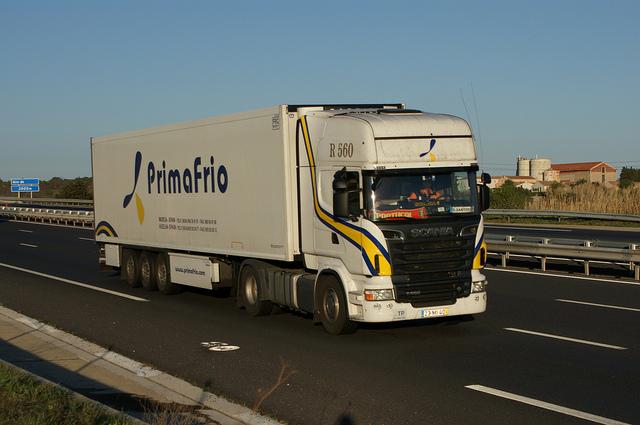What is this truck used for?
Answer briefly. Hauling goods. What kind of truck is this?
Answer briefly. Semi. Does this truck have a ladder in the back?
Quick response, please. No. What is the brand of the truck?
Give a very brief answer. Scania. Is the truck parked?
Short answer required. No. What color is the vehicle?
Concise answer only. White. Is the truck at a stop?
Quick response, please. No. What is written on the truck?
Answer briefly. Primafrio. What is the name of this truck?
Short answer required. Primafrio. Is this a house?
Short answer required. No. What color is the lead truck?
Short answer required. White. Is the truck traveling on an interstate?
Answer briefly. Yes. Is the person standing on the truck?
Short answer required. No. How many red braces can be seen?
Quick response, please. 0. Is this area rural?
Short answer required. Yes. Is the truck going to turn left?
Quick response, please. No. Is this a tow truck?
Quick response, please. No. Why is the roadway shiny?
Concise answer only. New. What are the round buildings in the background?
Be succinct. Silos. How many wheels are visible?
Quick response, please. 5. Is the vehicle moving?
Give a very brief answer. Yes. What kind of weather are they driving into?
Short answer required. Clear. Is this truck being inspected for illegal cargo?
Answer briefly. No. What is this truck transporting?
Answer briefly. Goods. Is the vehicle parked?
Write a very short answer. No. What type of vehicle is this?
Answer briefly. Truck. Is there a safe pedestrian crossing?
Short answer required. No. Are there any cars on the road?
Quick response, please. No. 